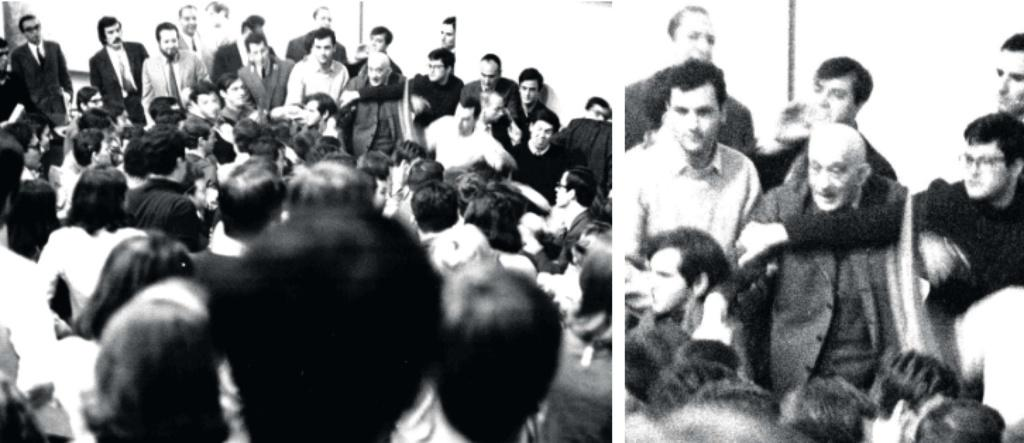How many images are combined to create the collage in the image? The image is a collage of 2 images. What can be observed in the images? There are many people in the images. What is the color scheme of the collage? The image is black and white. What type of hat is being worn by the person in the image? There is no person wearing a hat in the image, as it is a black and white collage of two images with many people. Can you see a zipper on any of the clothing in the image? There is no visible zipper on any clothing in the image, as it is a black and white collage of two images with many people. 